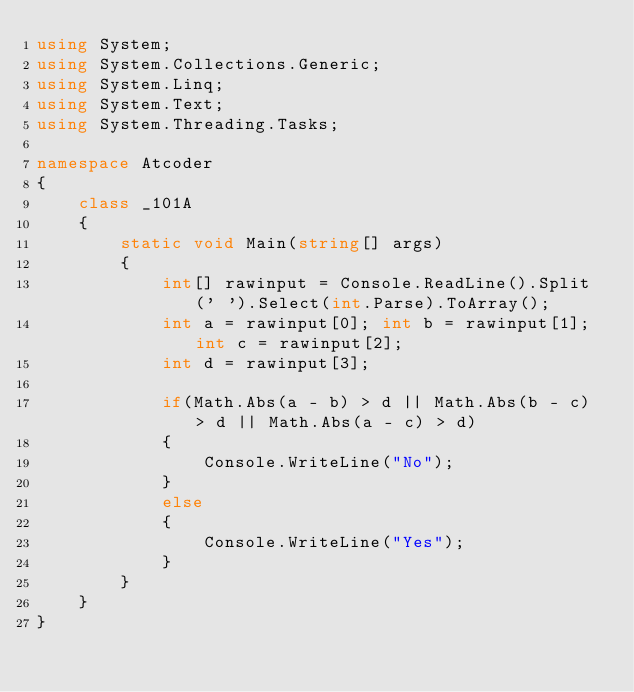Convert code to text. <code><loc_0><loc_0><loc_500><loc_500><_C#_>using System;
using System.Collections.Generic;
using System.Linq;
using System.Text;
using System.Threading.Tasks;

namespace Atcoder
{
    class _101A
    {
        static void Main(string[] args)
        {
            int[] rawinput = Console.ReadLine().Split(' ').Select(int.Parse).ToArray();
            int a = rawinput[0]; int b = rawinput[1]; int c = rawinput[2];
            int d = rawinput[3];
            
            if(Math.Abs(a - b) > d || Math.Abs(b - c) > d || Math.Abs(a - c) > d)
            {
                Console.WriteLine("No");
            }
            else
            {
                Console.WriteLine("Yes");
            }
        }
    }
}
</code> 